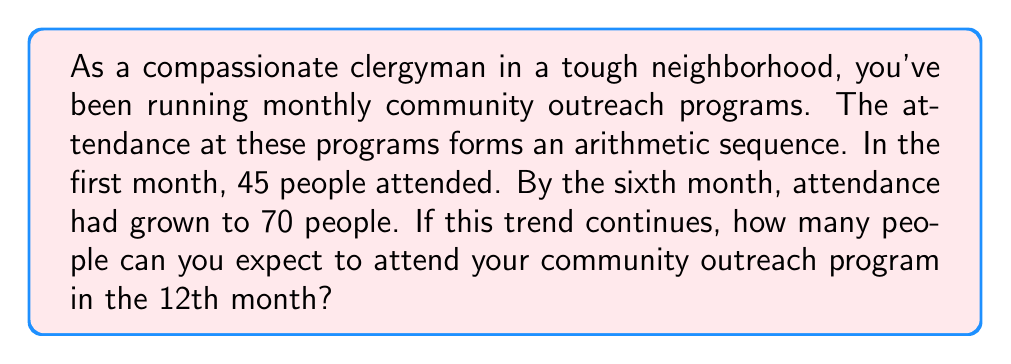Provide a solution to this math problem. Let's approach this step-by-step using the properties of arithmetic sequences:

1) In an arithmetic sequence, the difference between any two consecutive terms is constant. Let's call this common difference $d$.

2) We're given two points in the sequence:
   $a_1 = 45$ (1st term)
   $a_6 = 70$ (6th term)

3) In an arithmetic sequence, the nth term is given by the formula:
   $a_n = a_1 + (n-1)d$

4) We can use this to set up an equation:
   $70 = 45 + (6-1)d$
   $70 = 45 + 5d$

5) Solve for $d$:
   $25 = 5d$
   $d = 5$

6) Now that we know the common difference, we can find the 12th term:
   $a_{12} = a_1 + (12-1)d$
   $a_{12} = 45 + (11)(5)$
   $a_{12} = 45 + 55$
   $a_{12} = 100$

Therefore, if the trend continues, you can expect 100 people to attend the 12th month's community outreach program.
Answer: 100 people 